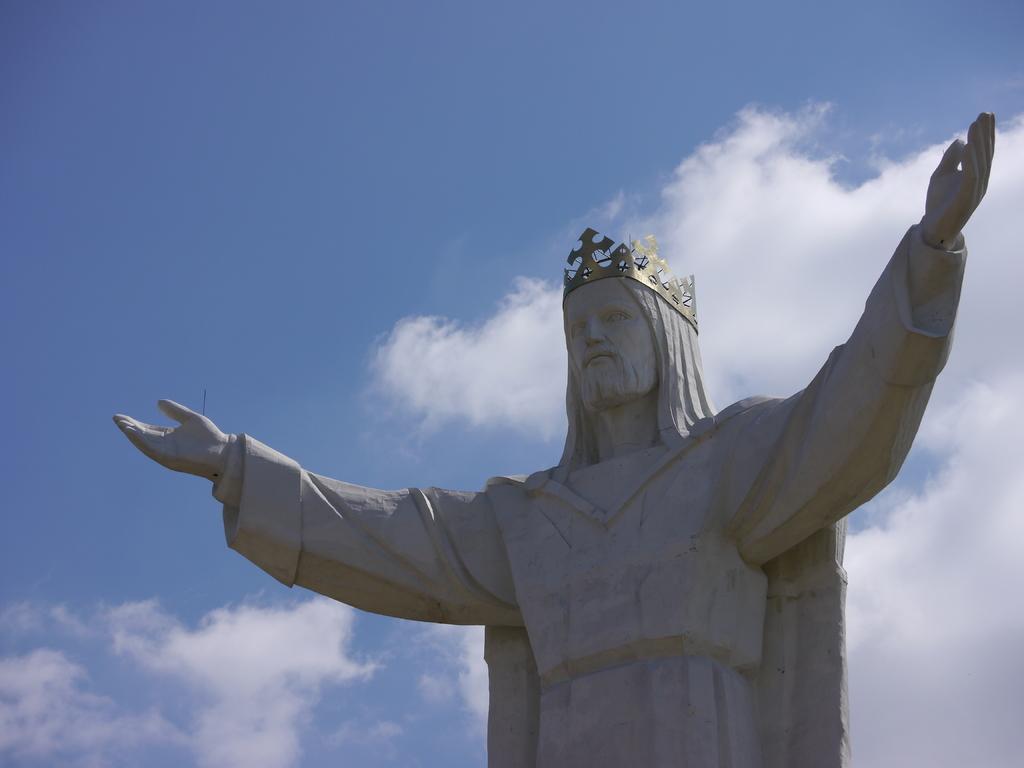In one or two sentences, can you explain what this image depicts? In this picture we can see a statue and in the background we can see sky with clouds. 